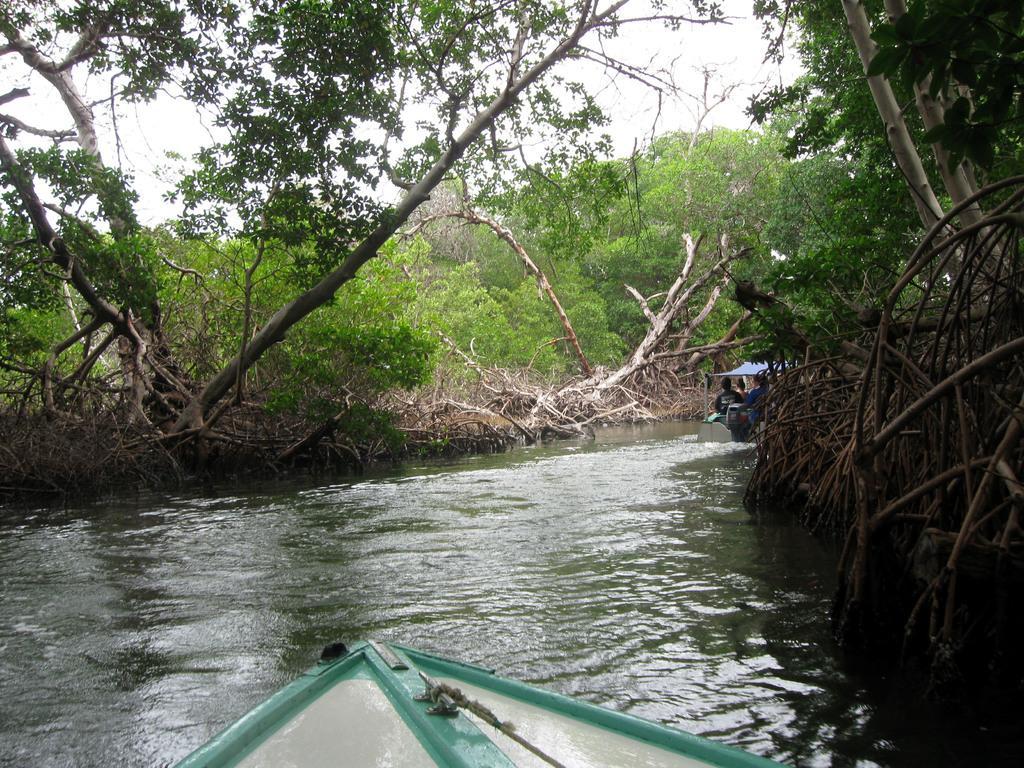Can you describe this image briefly? At the bottom of the image there is a canal and we can see boats on the canal. There are people sitting in the boats. In the background there are trees and sky. 